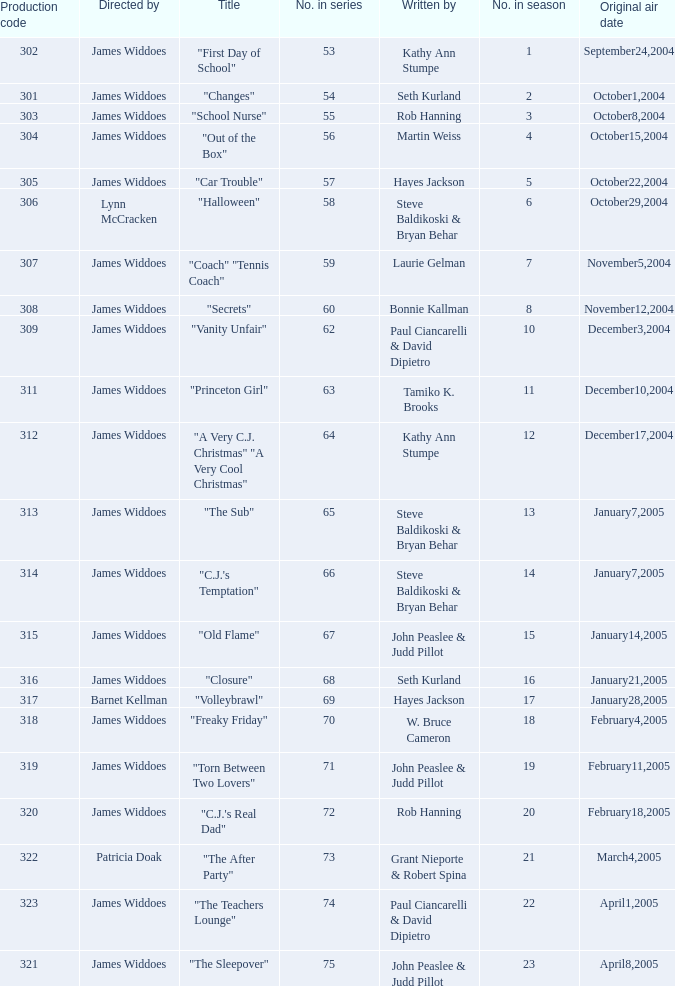Who directed "Freaky Friday"? James Widdoes. 